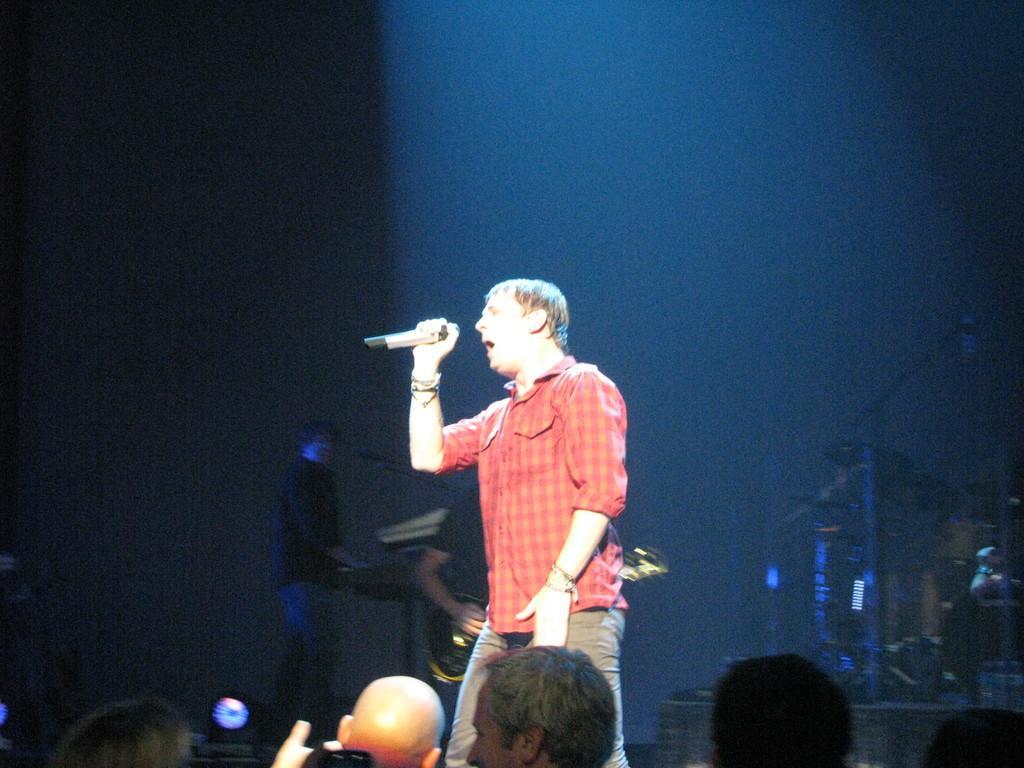Describe this image in one or two sentences. In this picture we can see a man in the orange shirt is holding a microphone and singing a song. In front of the man there are groups of people and behind the man there are some music instruments and a man is standing. Behind the people there is a dark background. 